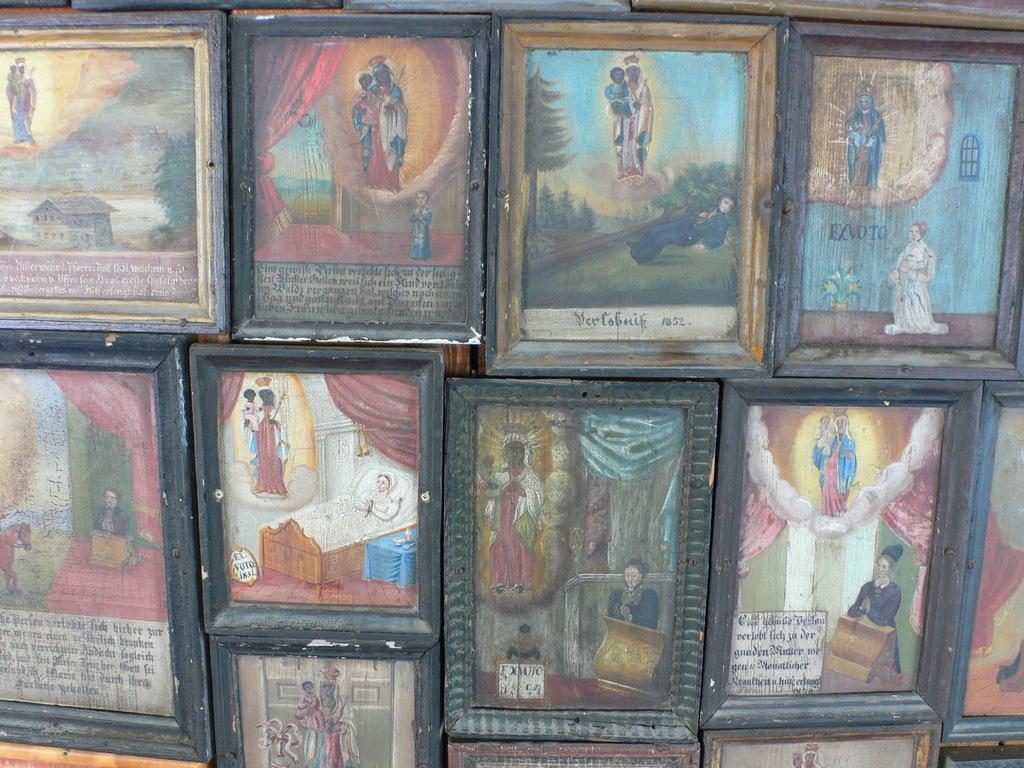All foreign language?
Make the answer very short. Yes. 